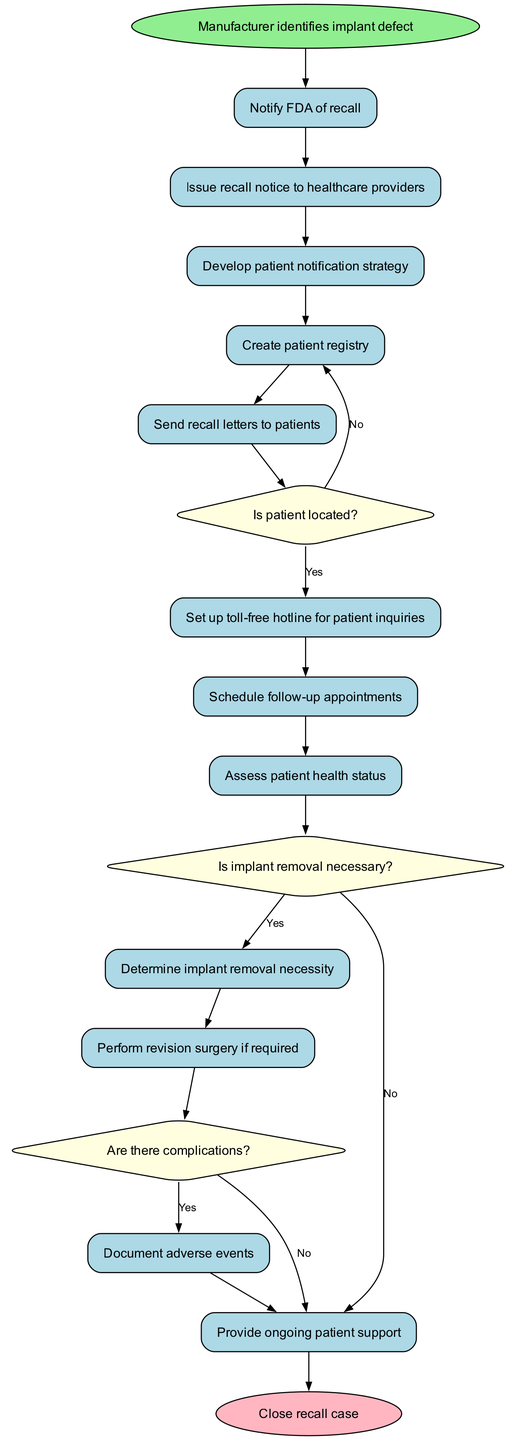What is the first activity in the recall process? The first activity in the diagram is identified directly from the starting point, which states "Manufacturer identifies implant defect."
Answer: Manufacturer identifies implant defect How many activities are involved in the recall procedure? The diagram lists 12 activities in total; this count includes all actions from notifying the FDA to providing ongoing patient support.
Answer: 12 What decision follows the activity 'Send recall letters to patients'? The decision that follows this activity is "Is patient located?" This is a direct connection from the previous activity to the decision node.
Answer: Is patient located? What happens if the answer to "Is implant removal necessary?" is yes? If the answer to this decision is yes, the process goes to the activity "Perform revision surgery if required," which indicates that removal and possible surgical intervention is necessary.
Answer: Perform revision surgery if required What is the last activity before closing the recall case? Before closing the recall case, the last activity is "Provide ongoing patient support," which precedes the end node in the flow of the diagram.
Answer: Provide ongoing patient support If the answer to "Are there complications?" is no, what is the next step? If there are no complications to the implant removal decision, the next activity is to provide ongoing patient support, indicating that no further immediate medical action is needed.
Answer: Provide ongoing patient support What decision occurs after assessing patient health status? The decision that occurs after this activity is "Is implant removal necessary?" which helps determine the next actions based on the patient's health assessment.
Answer: Is implant removal necessary? Identify the activity connected to the decision "Are there complications?" The activity connected to the decision "Are there complications?" is "Document adverse events," which shows that further actions depend on whether complications arise during the revision process.
Answer: Document adverse events 